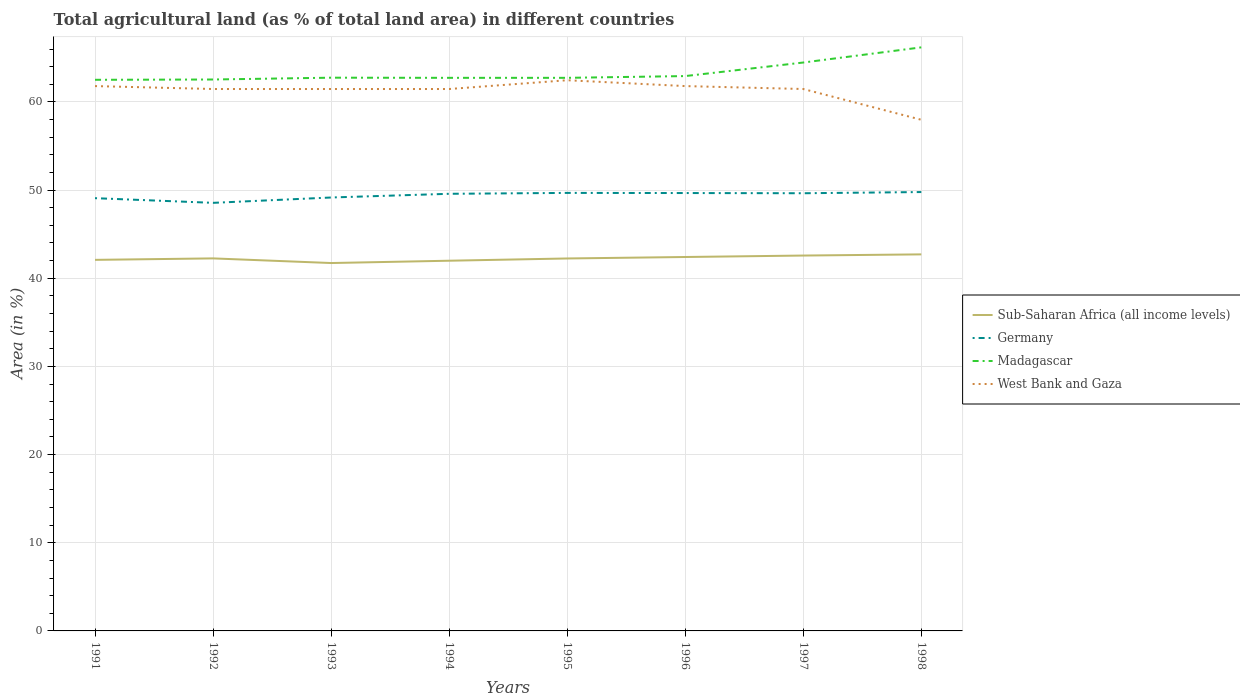Is the number of lines equal to the number of legend labels?
Keep it short and to the point. Yes. Across all years, what is the maximum percentage of agricultural land in Germany?
Your response must be concise. 48.55. What is the total percentage of agricultural land in Germany in the graph?
Your answer should be very brief. -0.09. What is the difference between the highest and the second highest percentage of agricultural land in Sub-Saharan Africa (all income levels)?
Provide a short and direct response. 0.98. What is the difference between the highest and the lowest percentage of agricultural land in Sub-Saharan Africa (all income levels)?
Ensure brevity in your answer.  4. What is the difference between two consecutive major ticks on the Y-axis?
Offer a very short reply. 10. Are the values on the major ticks of Y-axis written in scientific E-notation?
Provide a succinct answer. No. How many legend labels are there?
Keep it short and to the point. 4. How are the legend labels stacked?
Keep it short and to the point. Vertical. What is the title of the graph?
Give a very brief answer. Total agricultural land (as % of total land area) in different countries. Does "Guatemala" appear as one of the legend labels in the graph?
Your answer should be compact. No. What is the label or title of the X-axis?
Provide a succinct answer. Years. What is the label or title of the Y-axis?
Your response must be concise. Area (in %). What is the Area (in %) of Sub-Saharan Africa (all income levels) in 1991?
Your answer should be compact. 42.08. What is the Area (in %) in Germany in 1991?
Keep it short and to the point. 49.08. What is the Area (in %) of Madagascar in 1991?
Make the answer very short. 62.51. What is the Area (in %) in West Bank and Gaza in 1991?
Your answer should be very brief. 61.79. What is the Area (in %) in Sub-Saharan Africa (all income levels) in 1992?
Give a very brief answer. 42.25. What is the Area (in %) of Germany in 1992?
Offer a very short reply. 48.55. What is the Area (in %) in Madagascar in 1992?
Keep it short and to the point. 62.54. What is the Area (in %) of West Bank and Gaza in 1992?
Give a very brief answer. 61.46. What is the Area (in %) of Sub-Saharan Africa (all income levels) in 1993?
Your answer should be very brief. 41.72. What is the Area (in %) in Germany in 1993?
Provide a succinct answer. 49.16. What is the Area (in %) in Madagascar in 1993?
Your answer should be compact. 62.75. What is the Area (in %) of West Bank and Gaza in 1993?
Provide a succinct answer. 61.46. What is the Area (in %) in Sub-Saharan Africa (all income levels) in 1994?
Provide a short and direct response. 41.99. What is the Area (in %) in Germany in 1994?
Ensure brevity in your answer.  49.58. What is the Area (in %) of Madagascar in 1994?
Make the answer very short. 62.73. What is the Area (in %) in West Bank and Gaza in 1994?
Your answer should be compact. 61.46. What is the Area (in %) in Sub-Saharan Africa (all income levels) in 1995?
Provide a succinct answer. 42.24. What is the Area (in %) in Germany in 1995?
Ensure brevity in your answer.  49.68. What is the Area (in %) of Madagascar in 1995?
Offer a very short reply. 62.73. What is the Area (in %) of West Bank and Gaza in 1995?
Make the answer very short. 62.46. What is the Area (in %) of Sub-Saharan Africa (all income levels) in 1996?
Make the answer very short. 42.41. What is the Area (in %) of Germany in 1996?
Provide a short and direct response. 49.66. What is the Area (in %) of Madagascar in 1996?
Provide a succinct answer. 62.93. What is the Area (in %) in West Bank and Gaza in 1996?
Provide a succinct answer. 61.79. What is the Area (in %) of Sub-Saharan Africa (all income levels) in 1997?
Your answer should be very brief. 42.57. What is the Area (in %) of Germany in 1997?
Give a very brief answer. 49.64. What is the Area (in %) of Madagascar in 1997?
Your answer should be compact. 64.47. What is the Area (in %) of West Bank and Gaza in 1997?
Your answer should be compact. 61.46. What is the Area (in %) in Sub-Saharan Africa (all income levels) in 1998?
Your answer should be compact. 42.71. What is the Area (in %) in Germany in 1998?
Your answer should be very brief. 49.78. What is the Area (in %) in Madagascar in 1998?
Offer a terse response. 66.19. What is the Area (in %) of West Bank and Gaza in 1998?
Provide a succinct answer. 57.97. Across all years, what is the maximum Area (in %) of Sub-Saharan Africa (all income levels)?
Provide a short and direct response. 42.71. Across all years, what is the maximum Area (in %) in Germany?
Your answer should be very brief. 49.78. Across all years, what is the maximum Area (in %) of Madagascar?
Give a very brief answer. 66.19. Across all years, what is the maximum Area (in %) of West Bank and Gaza?
Your answer should be very brief. 62.46. Across all years, what is the minimum Area (in %) in Sub-Saharan Africa (all income levels)?
Your answer should be compact. 41.72. Across all years, what is the minimum Area (in %) of Germany?
Make the answer very short. 48.55. Across all years, what is the minimum Area (in %) of Madagascar?
Your answer should be very brief. 62.51. Across all years, what is the minimum Area (in %) of West Bank and Gaza?
Make the answer very short. 57.97. What is the total Area (in %) in Sub-Saharan Africa (all income levels) in the graph?
Offer a very short reply. 337.98. What is the total Area (in %) in Germany in the graph?
Ensure brevity in your answer.  395.13. What is the total Area (in %) of Madagascar in the graph?
Offer a very short reply. 506.84. What is the total Area (in %) in West Bank and Gaza in the graph?
Make the answer very short. 489.87. What is the difference between the Area (in %) of Sub-Saharan Africa (all income levels) in 1991 and that in 1992?
Provide a succinct answer. -0.17. What is the difference between the Area (in %) in Germany in 1991 and that in 1992?
Give a very brief answer. 0.53. What is the difference between the Area (in %) in Madagascar in 1991 and that in 1992?
Offer a very short reply. -0.03. What is the difference between the Area (in %) in West Bank and Gaza in 1991 and that in 1992?
Offer a very short reply. 0.33. What is the difference between the Area (in %) of Sub-Saharan Africa (all income levels) in 1991 and that in 1993?
Your answer should be very brief. 0.36. What is the difference between the Area (in %) of Germany in 1991 and that in 1993?
Give a very brief answer. -0.08. What is the difference between the Area (in %) in Madagascar in 1991 and that in 1993?
Your answer should be compact. -0.24. What is the difference between the Area (in %) in West Bank and Gaza in 1991 and that in 1993?
Provide a short and direct response. 0.33. What is the difference between the Area (in %) in Sub-Saharan Africa (all income levels) in 1991 and that in 1994?
Your answer should be compact. 0.1. What is the difference between the Area (in %) in Germany in 1991 and that in 1994?
Provide a succinct answer. -0.5. What is the difference between the Area (in %) of Madagascar in 1991 and that in 1994?
Keep it short and to the point. -0.22. What is the difference between the Area (in %) of West Bank and Gaza in 1991 and that in 1994?
Ensure brevity in your answer.  0.33. What is the difference between the Area (in %) in Sub-Saharan Africa (all income levels) in 1991 and that in 1995?
Offer a very short reply. -0.16. What is the difference between the Area (in %) of Germany in 1991 and that in 1995?
Your answer should be compact. -0.6. What is the difference between the Area (in %) in Madagascar in 1991 and that in 1995?
Give a very brief answer. -0.22. What is the difference between the Area (in %) of West Bank and Gaza in 1991 and that in 1995?
Make the answer very short. -0.66. What is the difference between the Area (in %) in Sub-Saharan Africa (all income levels) in 1991 and that in 1996?
Provide a short and direct response. -0.32. What is the difference between the Area (in %) of Germany in 1991 and that in 1996?
Provide a short and direct response. -0.58. What is the difference between the Area (in %) in Madagascar in 1991 and that in 1996?
Your response must be concise. -0.42. What is the difference between the Area (in %) of Sub-Saharan Africa (all income levels) in 1991 and that in 1997?
Provide a succinct answer. -0.49. What is the difference between the Area (in %) in Germany in 1991 and that in 1997?
Offer a terse response. -0.56. What is the difference between the Area (in %) of Madagascar in 1991 and that in 1997?
Make the answer very short. -1.96. What is the difference between the Area (in %) in West Bank and Gaza in 1991 and that in 1997?
Offer a very short reply. 0.33. What is the difference between the Area (in %) in Sub-Saharan Africa (all income levels) in 1991 and that in 1998?
Keep it short and to the point. -0.62. What is the difference between the Area (in %) in Germany in 1991 and that in 1998?
Give a very brief answer. -0.69. What is the difference between the Area (in %) of Madagascar in 1991 and that in 1998?
Offer a very short reply. -3.68. What is the difference between the Area (in %) of West Bank and Gaza in 1991 and that in 1998?
Provide a succinct answer. 3.82. What is the difference between the Area (in %) in Sub-Saharan Africa (all income levels) in 1992 and that in 1993?
Ensure brevity in your answer.  0.53. What is the difference between the Area (in %) of Germany in 1992 and that in 1993?
Your answer should be compact. -0.61. What is the difference between the Area (in %) in Madagascar in 1992 and that in 1993?
Offer a terse response. -0.21. What is the difference between the Area (in %) of Sub-Saharan Africa (all income levels) in 1992 and that in 1994?
Your response must be concise. 0.26. What is the difference between the Area (in %) in Germany in 1992 and that in 1994?
Offer a terse response. -1.03. What is the difference between the Area (in %) of Madagascar in 1992 and that in 1994?
Offer a very short reply. -0.19. What is the difference between the Area (in %) in Sub-Saharan Africa (all income levels) in 1992 and that in 1995?
Your response must be concise. 0.01. What is the difference between the Area (in %) of Germany in 1992 and that in 1995?
Offer a very short reply. -1.13. What is the difference between the Area (in %) of Madagascar in 1992 and that in 1995?
Provide a short and direct response. -0.19. What is the difference between the Area (in %) in West Bank and Gaza in 1992 and that in 1995?
Ensure brevity in your answer.  -1. What is the difference between the Area (in %) of Sub-Saharan Africa (all income levels) in 1992 and that in 1996?
Offer a terse response. -0.16. What is the difference between the Area (in %) in Germany in 1992 and that in 1996?
Provide a succinct answer. -1.11. What is the difference between the Area (in %) in Madagascar in 1992 and that in 1996?
Keep it short and to the point. -0.39. What is the difference between the Area (in %) in West Bank and Gaza in 1992 and that in 1996?
Make the answer very short. -0.33. What is the difference between the Area (in %) in Sub-Saharan Africa (all income levels) in 1992 and that in 1997?
Provide a short and direct response. -0.32. What is the difference between the Area (in %) in Germany in 1992 and that in 1997?
Offer a very short reply. -1.09. What is the difference between the Area (in %) in Madagascar in 1992 and that in 1997?
Your answer should be very brief. -1.93. What is the difference between the Area (in %) in Sub-Saharan Africa (all income levels) in 1992 and that in 1998?
Your answer should be very brief. -0.46. What is the difference between the Area (in %) in Germany in 1992 and that in 1998?
Give a very brief answer. -1.22. What is the difference between the Area (in %) in Madagascar in 1992 and that in 1998?
Your answer should be very brief. -3.65. What is the difference between the Area (in %) of West Bank and Gaza in 1992 and that in 1998?
Give a very brief answer. 3.49. What is the difference between the Area (in %) of Sub-Saharan Africa (all income levels) in 1993 and that in 1994?
Provide a short and direct response. -0.26. What is the difference between the Area (in %) of Germany in 1993 and that in 1994?
Ensure brevity in your answer.  -0.42. What is the difference between the Area (in %) of Madagascar in 1993 and that in 1994?
Your response must be concise. 0.02. What is the difference between the Area (in %) of Sub-Saharan Africa (all income levels) in 1993 and that in 1995?
Your answer should be compact. -0.52. What is the difference between the Area (in %) in Germany in 1993 and that in 1995?
Provide a short and direct response. -0.52. What is the difference between the Area (in %) of Madagascar in 1993 and that in 1995?
Make the answer very short. 0.02. What is the difference between the Area (in %) in West Bank and Gaza in 1993 and that in 1995?
Offer a very short reply. -1. What is the difference between the Area (in %) of Sub-Saharan Africa (all income levels) in 1993 and that in 1996?
Your answer should be compact. -0.68. What is the difference between the Area (in %) in Germany in 1993 and that in 1996?
Your answer should be very brief. -0.51. What is the difference between the Area (in %) in Madagascar in 1993 and that in 1996?
Offer a very short reply. -0.18. What is the difference between the Area (in %) in West Bank and Gaza in 1993 and that in 1996?
Your answer should be very brief. -0.33. What is the difference between the Area (in %) in Sub-Saharan Africa (all income levels) in 1993 and that in 1997?
Make the answer very short. -0.85. What is the difference between the Area (in %) of Germany in 1993 and that in 1997?
Ensure brevity in your answer.  -0.48. What is the difference between the Area (in %) in Madagascar in 1993 and that in 1997?
Make the answer very short. -1.72. What is the difference between the Area (in %) of Sub-Saharan Africa (all income levels) in 1993 and that in 1998?
Provide a succinct answer. -0.98. What is the difference between the Area (in %) in Germany in 1993 and that in 1998?
Make the answer very short. -0.62. What is the difference between the Area (in %) in Madagascar in 1993 and that in 1998?
Keep it short and to the point. -3.44. What is the difference between the Area (in %) in West Bank and Gaza in 1993 and that in 1998?
Offer a terse response. 3.49. What is the difference between the Area (in %) in Sub-Saharan Africa (all income levels) in 1994 and that in 1995?
Keep it short and to the point. -0.26. What is the difference between the Area (in %) of Germany in 1994 and that in 1995?
Keep it short and to the point. -0.1. What is the difference between the Area (in %) of Madagascar in 1994 and that in 1995?
Provide a short and direct response. 0. What is the difference between the Area (in %) of West Bank and Gaza in 1994 and that in 1995?
Your response must be concise. -1. What is the difference between the Area (in %) in Sub-Saharan Africa (all income levels) in 1994 and that in 1996?
Your answer should be very brief. -0.42. What is the difference between the Area (in %) in Germany in 1994 and that in 1996?
Ensure brevity in your answer.  -0.09. What is the difference between the Area (in %) in Madagascar in 1994 and that in 1996?
Your answer should be compact. -0.2. What is the difference between the Area (in %) in West Bank and Gaza in 1994 and that in 1996?
Give a very brief answer. -0.33. What is the difference between the Area (in %) in Sub-Saharan Africa (all income levels) in 1994 and that in 1997?
Provide a short and direct response. -0.59. What is the difference between the Area (in %) in Germany in 1994 and that in 1997?
Provide a succinct answer. -0.06. What is the difference between the Area (in %) of Madagascar in 1994 and that in 1997?
Make the answer very short. -1.74. What is the difference between the Area (in %) in West Bank and Gaza in 1994 and that in 1997?
Your answer should be compact. 0. What is the difference between the Area (in %) in Sub-Saharan Africa (all income levels) in 1994 and that in 1998?
Your answer should be very brief. -0.72. What is the difference between the Area (in %) in Germany in 1994 and that in 1998?
Offer a terse response. -0.2. What is the difference between the Area (in %) in Madagascar in 1994 and that in 1998?
Provide a succinct answer. -3.46. What is the difference between the Area (in %) of West Bank and Gaza in 1994 and that in 1998?
Your answer should be compact. 3.49. What is the difference between the Area (in %) of Sub-Saharan Africa (all income levels) in 1995 and that in 1996?
Keep it short and to the point. -0.17. What is the difference between the Area (in %) in Germany in 1995 and that in 1996?
Offer a very short reply. 0.02. What is the difference between the Area (in %) of Madagascar in 1995 and that in 1996?
Make the answer very short. -0.2. What is the difference between the Area (in %) of West Bank and Gaza in 1995 and that in 1996?
Ensure brevity in your answer.  0.66. What is the difference between the Area (in %) in Sub-Saharan Africa (all income levels) in 1995 and that in 1997?
Offer a very short reply. -0.33. What is the difference between the Area (in %) of Germany in 1995 and that in 1997?
Make the answer very short. 0.04. What is the difference between the Area (in %) in Madagascar in 1995 and that in 1997?
Offer a very short reply. -1.74. What is the difference between the Area (in %) of West Bank and Gaza in 1995 and that in 1997?
Your answer should be compact. 1. What is the difference between the Area (in %) in Sub-Saharan Africa (all income levels) in 1995 and that in 1998?
Give a very brief answer. -0.46. What is the difference between the Area (in %) of Germany in 1995 and that in 1998?
Provide a succinct answer. -0.1. What is the difference between the Area (in %) of Madagascar in 1995 and that in 1998?
Provide a short and direct response. -3.46. What is the difference between the Area (in %) in West Bank and Gaza in 1995 and that in 1998?
Provide a succinct answer. 4.49. What is the difference between the Area (in %) in Sub-Saharan Africa (all income levels) in 1996 and that in 1997?
Ensure brevity in your answer.  -0.17. What is the difference between the Area (in %) in Germany in 1996 and that in 1997?
Provide a succinct answer. 0.02. What is the difference between the Area (in %) in Madagascar in 1996 and that in 1997?
Give a very brief answer. -1.54. What is the difference between the Area (in %) in West Bank and Gaza in 1996 and that in 1997?
Make the answer very short. 0.33. What is the difference between the Area (in %) in Sub-Saharan Africa (all income levels) in 1996 and that in 1998?
Provide a succinct answer. -0.3. What is the difference between the Area (in %) of Germany in 1996 and that in 1998?
Offer a very short reply. -0.11. What is the difference between the Area (in %) of Madagascar in 1996 and that in 1998?
Provide a succinct answer. -3.26. What is the difference between the Area (in %) in West Bank and Gaza in 1996 and that in 1998?
Provide a short and direct response. 3.82. What is the difference between the Area (in %) of Sub-Saharan Africa (all income levels) in 1997 and that in 1998?
Offer a very short reply. -0.13. What is the difference between the Area (in %) in Germany in 1997 and that in 1998?
Offer a very short reply. -0.14. What is the difference between the Area (in %) in Madagascar in 1997 and that in 1998?
Give a very brief answer. -1.72. What is the difference between the Area (in %) in West Bank and Gaza in 1997 and that in 1998?
Provide a succinct answer. 3.49. What is the difference between the Area (in %) in Sub-Saharan Africa (all income levels) in 1991 and the Area (in %) in Germany in 1992?
Provide a short and direct response. -6.47. What is the difference between the Area (in %) of Sub-Saharan Africa (all income levels) in 1991 and the Area (in %) of Madagascar in 1992?
Give a very brief answer. -20.46. What is the difference between the Area (in %) in Sub-Saharan Africa (all income levels) in 1991 and the Area (in %) in West Bank and Gaza in 1992?
Your response must be concise. -19.38. What is the difference between the Area (in %) of Germany in 1991 and the Area (in %) of Madagascar in 1992?
Give a very brief answer. -13.46. What is the difference between the Area (in %) of Germany in 1991 and the Area (in %) of West Bank and Gaza in 1992?
Ensure brevity in your answer.  -12.38. What is the difference between the Area (in %) of Madagascar in 1991 and the Area (in %) of West Bank and Gaza in 1992?
Provide a succinct answer. 1.04. What is the difference between the Area (in %) of Sub-Saharan Africa (all income levels) in 1991 and the Area (in %) of Germany in 1993?
Offer a terse response. -7.07. What is the difference between the Area (in %) in Sub-Saharan Africa (all income levels) in 1991 and the Area (in %) in Madagascar in 1993?
Provide a succinct answer. -20.66. What is the difference between the Area (in %) in Sub-Saharan Africa (all income levels) in 1991 and the Area (in %) in West Bank and Gaza in 1993?
Give a very brief answer. -19.38. What is the difference between the Area (in %) in Germany in 1991 and the Area (in %) in Madagascar in 1993?
Make the answer very short. -13.67. What is the difference between the Area (in %) of Germany in 1991 and the Area (in %) of West Bank and Gaza in 1993?
Your answer should be very brief. -12.38. What is the difference between the Area (in %) in Madagascar in 1991 and the Area (in %) in West Bank and Gaza in 1993?
Make the answer very short. 1.04. What is the difference between the Area (in %) of Sub-Saharan Africa (all income levels) in 1991 and the Area (in %) of Germany in 1994?
Your answer should be compact. -7.49. What is the difference between the Area (in %) in Sub-Saharan Africa (all income levels) in 1991 and the Area (in %) in Madagascar in 1994?
Your answer should be very brief. -20.65. What is the difference between the Area (in %) in Sub-Saharan Africa (all income levels) in 1991 and the Area (in %) in West Bank and Gaza in 1994?
Ensure brevity in your answer.  -19.38. What is the difference between the Area (in %) of Germany in 1991 and the Area (in %) of Madagascar in 1994?
Provide a short and direct response. -13.65. What is the difference between the Area (in %) in Germany in 1991 and the Area (in %) in West Bank and Gaza in 1994?
Give a very brief answer. -12.38. What is the difference between the Area (in %) of Madagascar in 1991 and the Area (in %) of West Bank and Gaza in 1994?
Provide a short and direct response. 1.04. What is the difference between the Area (in %) of Sub-Saharan Africa (all income levels) in 1991 and the Area (in %) of Germany in 1995?
Provide a succinct answer. -7.59. What is the difference between the Area (in %) in Sub-Saharan Africa (all income levels) in 1991 and the Area (in %) in Madagascar in 1995?
Provide a short and direct response. -20.65. What is the difference between the Area (in %) of Sub-Saharan Africa (all income levels) in 1991 and the Area (in %) of West Bank and Gaza in 1995?
Provide a short and direct response. -20.37. What is the difference between the Area (in %) of Germany in 1991 and the Area (in %) of Madagascar in 1995?
Your answer should be very brief. -13.65. What is the difference between the Area (in %) in Germany in 1991 and the Area (in %) in West Bank and Gaza in 1995?
Your answer should be very brief. -13.38. What is the difference between the Area (in %) of Madagascar in 1991 and the Area (in %) of West Bank and Gaza in 1995?
Give a very brief answer. 0.05. What is the difference between the Area (in %) in Sub-Saharan Africa (all income levels) in 1991 and the Area (in %) in Germany in 1996?
Offer a terse response. -7.58. What is the difference between the Area (in %) of Sub-Saharan Africa (all income levels) in 1991 and the Area (in %) of Madagascar in 1996?
Ensure brevity in your answer.  -20.84. What is the difference between the Area (in %) of Sub-Saharan Africa (all income levels) in 1991 and the Area (in %) of West Bank and Gaza in 1996?
Your answer should be very brief. -19.71. What is the difference between the Area (in %) in Germany in 1991 and the Area (in %) in Madagascar in 1996?
Ensure brevity in your answer.  -13.85. What is the difference between the Area (in %) in Germany in 1991 and the Area (in %) in West Bank and Gaza in 1996?
Offer a very short reply. -12.71. What is the difference between the Area (in %) of Madagascar in 1991 and the Area (in %) of West Bank and Gaza in 1996?
Offer a terse response. 0.71. What is the difference between the Area (in %) of Sub-Saharan Africa (all income levels) in 1991 and the Area (in %) of Germany in 1997?
Your answer should be compact. -7.56. What is the difference between the Area (in %) in Sub-Saharan Africa (all income levels) in 1991 and the Area (in %) in Madagascar in 1997?
Provide a succinct answer. -22.38. What is the difference between the Area (in %) of Sub-Saharan Africa (all income levels) in 1991 and the Area (in %) of West Bank and Gaza in 1997?
Keep it short and to the point. -19.38. What is the difference between the Area (in %) in Germany in 1991 and the Area (in %) in Madagascar in 1997?
Make the answer very short. -15.38. What is the difference between the Area (in %) of Germany in 1991 and the Area (in %) of West Bank and Gaza in 1997?
Keep it short and to the point. -12.38. What is the difference between the Area (in %) in Madagascar in 1991 and the Area (in %) in West Bank and Gaza in 1997?
Provide a succinct answer. 1.04. What is the difference between the Area (in %) in Sub-Saharan Africa (all income levels) in 1991 and the Area (in %) in Germany in 1998?
Make the answer very short. -7.69. What is the difference between the Area (in %) of Sub-Saharan Africa (all income levels) in 1991 and the Area (in %) of Madagascar in 1998?
Give a very brief answer. -24.1. What is the difference between the Area (in %) in Sub-Saharan Africa (all income levels) in 1991 and the Area (in %) in West Bank and Gaza in 1998?
Your answer should be very brief. -15.89. What is the difference between the Area (in %) of Germany in 1991 and the Area (in %) of Madagascar in 1998?
Give a very brief answer. -17.1. What is the difference between the Area (in %) of Germany in 1991 and the Area (in %) of West Bank and Gaza in 1998?
Keep it short and to the point. -8.89. What is the difference between the Area (in %) of Madagascar in 1991 and the Area (in %) of West Bank and Gaza in 1998?
Your response must be concise. 4.53. What is the difference between the Area (in %) in Sub-Saharan Africa (all income levels) in 1992 and the Area (in %) in Germany in 1993?
Make the answer very short. -6.91. What is the difference between the Area (in %) in Sub-Saharan Africa (all income levels) in 1992 and the Area (in %) in Madagascar in 1993?
Your answer should be very brief. -20.5. What is the difference between the Area (in %) of Sub-Saharan Africa (all income levels) in 1992 and the Area (in %) of West Bank and Gaza in 1993?
Your response must be concise. -19.21. What is the difference between the Area (in %) of Germany in 1992 and the Area (in %) of Madagascar in 1993?
Give a very brief answer. -14.2. What is the difference between the Area (in %) in Germany in 1992 and the Area (in %) in West Bank and Gaza in 1993?
Offer a terse response. -12.91. What is the difference between the Area (in %) of Madagascar in 1992 and the Area (in %) of West Bank and Gaza in 1993?
Keep it short and to the point. 1.08. What is the difference between the Area (in %) in Sub-Saharan Africa (all income levels) in 1992 and the Area (in %) in Germany in 1994?
Give a very brief answer. -7.33. What is the difference between the Area (in %) of Sub-Saharan Africa (all income levels) in 1992 and the Area (in %) of Madagascar in 1994?
Your response must be concise. -20.48. What is the difference between the Area (in %) of Sub-Saharan Africa (all income levels) in 1992 and the Area (in %) of West Bank and Gaza in 1994?
Provide a succinct answer. -19.21. What is the difference between the Area (in %) in Germany in 1992 and the Area (in %) in Madagascar in 1994?
Offer a very short reply. -14.18. What is the difference between the Area (in %) of Germany in 1992 and the Area (in %) of West Bank and Gaza in 1994?
Keep it short and to the point. -12.91. What is the difference between the Area (in %) in Madagascar in 1992 and the Area (in %) in West Bank and Gaza in 1994?
Ensure brevity in your answer.  1.08. What is the difference between the Area (in %) in Sub-Saharan Africa (all income levels) in 1992 and the Area (in %) in Germany in 1995?
Give a very brief answer. -7.43. What is the difference between the Area (in %) in Sub-Saharan Africa (all income levels) in 1992 and the Area (in %) in Madagascar in 1995?
Your response must be concise. -20.48. What is the difference between the Area (in %) in Sub-Saharan Africa (all income levels) in 1992 and the Area (in %) in West Bank and Gaza in 1995?
Offer a terse response. -20.21. What is the difference between the Area (in %) in Germany in 1992 and the Area (in %) in Madagascar in 1995?
Your answer should be very brief. -14.18. What is the difference between the Area (in %) in Germany in 1992 and the Area (in %) in West Bank and Gaza in 1995?
Your response must be concise. -13.91. What is the difference between the Area (in %) in Madagascar in 1992 and the Area (in %) in West Bank and Gaza in 1995?
Provide a short and direct response. 0.08. What is the difference between the Area (in %) of Sub-Saharan Africa (all income levels) in 1992 and the Area (in %) of Germany in 1996?
Offer a terse response. -7.41. What is the difference between the Area (in %) in Sub-Saharan Africa (all income levels) in 1992 and the Area (in %) in Madagascar in 1996?
Give a very brief answer. -20.68. What is the difference between the Area (in %) of Sub-Saharan Africa (all income levels) in 1992 and the Area (in %) of West Bank and Gaza in 1996?
Keep it short and to the point. -19.54. What is the difference between the Area (in %) in Germany in 1992 and the Area (in %) in Madagascar in 1996?
Your answer should be compact. -14.38. What is the difference between the Area (in %) of Germany in 1992 and the Area (in %) of West Bank and Gaza in 1996?
Offer a terse response. -13.24. What is the difference between the Area (in %) in Madagascar in 1992 and the Area (in %) in West Bank and Gaza in 1996?
Your response must be concise. 0.75. What is the difference between the Area (in %) in Sub-Saharan Africa (all income levels) in 1992 and the Area (in %) in Germany in 1997?
Make the answer very short. -7.39. What is the difference between the Area (in %) in Sub-Saharan Africa (all income levels) in 1992 and the Area (in %) in Madagascar in 1997?
Ensure brevity in your answer.  -22.22. What is the difference between the Area (in %) in Sub-Saharan Africa (all income levels) in 1992 and the Area (in %) in West Bank and Gaza in 1997?
Offer a terse response. -19.21. What is the difference between the Area (in %) in Germany in 1992 and the Area (in %) in Madagascar in 1997?
Your answer should be very brief. -15.91. What is the difference between the Area (in %) of Germany in 1992 and the Area (in %) of West Bank and Gaza in 1997?
Offer a very short reply. -12.91. What is the difference between the Area (in %) of Madagascar in 1992 and the Area (in %) of West Bank and Gaza in 1997?
Give a very brief answer. 1.08. What is the difference between the Area (in %) of Sub-Saharan Africa (all income levels) in 1992 and the Area (in %) of Germany in 1998?
Make the answer very short. -7.53. What is the difference between the Area (in %) in Sub-Saharan Africa (all income levels) in 1992 and the Area (in %) in Madagascar in 1998?
Offer a very short reply. -23.94. What is the difference between the Area (in %) in Sub-Saharan Africa (all income levels) in 1992 and the Area (in %) in West Bank and Gaza in 1998?
Offer a terse response. -15.72. What is the difference between the Area (in %) in Germany in 1992 and the Area (in %) in Madagascar in 1998?
Provide a short and direct response. -17.63. What is the difference between the Area (in %) of Germany in 1992 and the Area (in %) of West Bank and Gaza in 1998?
Provide a short and direct response. -9.42. What is the difference between the Area (in %) in Madagascar in 1992 and the Area (in %) in West Bank and Gaza in 1998?
Ensure brevity in your answer.  4.57. What is the difference between the Area (in %) of Sub-Saharan Africa (all income levels) in 1993 and the Area (in %) of Germany in 1994?
Offer a terse response. -7.85. What is the difference between the Area (in %) of Sub-Saharan Africa (all income levels) in 1993 and the Area (in %) of Madagascar in 1994?
Keep it short and to the point. -21.01. What is the difference between the Area (in %) of Sub-Saharan Africa (all income levels) in 1993 and the Area (in %) of West Bank and Gaza in 1994?
Offer a terse response. -19.74. What is the difference between the Area (in %) of Germany in 1993 and the Area (in %) of Madagascar in 1994?
Make the answer very short. -13.57. What is the difference between the Area (in %) of Germany in 1993 and the Area (in %) of West Bank and Gaza in 1994?
Ensure brevity in your answer.  -12.3. What is the difference between the Area (in %) in Madagascar in 1993 and the Area (in %) in West Bank and Gaza in 1994?
Your response must be concise. 1.29. What is the difference between the Area (in %) in Sub-Saharan Africa (all income levels) in 1993 and the Area (in %) in Germany in 1995?
Your answer should be very brief. -7.95. What is the difference between the Area (in %) of Sub-Saharan Africa (all income levels) in 1993 and the Area (in %) of Madagascar in 1995?
Provide a short and direct response. -21.01. What is the difference between the Area (in %) in Sub-Saharan Africa (all income levels) in 1993 and the Area (in %) in West Bank and Gaza in 1995?
Provide a short and direct response. -20.73. What is the difference between the Area (in %) of Germany in 1993 and the Area (in %) of Madagascar in 1995?
Make the answer very short. -13.57. What is the difference between the Area (in %) of Germany in 1993 and the Area (in %) of West Bank and Gaza in 1995?
Your answer should be compact. -13.3. What is the difference between the Area (in %) of Madagascar in 1993 and the Area (in %) of West Bank and Gaza in 1995?
Your answer should be very brief. 0.29. What is the difference between the Area (in %) of Sub-Saharan Africa (all income levels) in 1993 and the Area (in %) of Germany in 1996?
Your response must be concise. -7.94. What is the difference between the Area (in %) in Sub-Saharan Africa (all income levels) in 1993 and the Area (in %) in Madagascar in 1996?
Offer a terse response. -21.2. What is the difference between the Area (in %) in Sub-Saharan Africa (all income levels) in 1993 and the Area (in %) in West Bank and Gaza in 1996?
Ensure brevity in your answer.  -20.07. What is the difference between the Area (in %) in Germany in 1993 and the Area (in %) in Madagascar in 1996?
Ensure brevity in your answer.  -13.77. What is the difference between the Area (in %) of Germany in 1993 and the Area (in %) of West Bank and Gaza in 1996?
Give a very brief answer. -12.64. What is the difference between the Area (in %) of Madagascar in 1993 and the Area (in %) of West Bank and Gaza in 1996?
Offer a very short reply. 0.95. What is the difference between the Area (in %) in Sub-Saharan Africa (all income levels) in 1993 and the Area (in %) in Germany in 1997?
Provide a succinct answer. -7.92. What is the difference between the Area (in %) of Sub-Saharan Africa (all income levels) in 1993 and the Area (in %) of Madagascar in 1997?
Offer a very short reply. -22.74. What is the difference between the Area (in %) of Sub-Saharan Africa (all income levels) in 1993 and the Area (in %) of West Bank and Gaza in 1997?
Ensure brevity in your answer.  -19.74. What is the difference between the Area (in %) in Germany in 1993 and the Area (in %) in Madagascar in 1997?
Give a very brief answer. -15.31. What is the difference between the Area (in %) in Germany in 1993 and the Area (in %) in West Bank and Gaza in 1997?
Make the answer very short. -12.3. What is the difference between the Area (in %) in Madagascar in 1993 and the Area (in %) in West Bank and Gaza in 1997?
Your answer should be very brief. 1.29. What is the difference between the Area (in %) in Sub-Saharan Africa (all income levels) in 1993 and the Area (in %) in Germany in 1998?
Your answer should be compact. -8.05. What is the difference between the Area (in %) in Sub-Saharan Africa (all income levels) in 1993 and the Area (in %) in Madagascar in 1998?
Your answer should be very brief. -24.46. What is the difference between the Area (in %) of Sub-Saharan Africa (all income levels) in 1993 and the Area (in %) of West Bank and Gaza in 1998?
Your answer should be very brief. -16.25. What is the difference between the Area (in %) of Germany in 1993 and the Area (in %) of Madagascar in 1998?
Provide a short and direct response. -17.03. What is the difference between the Area (in %) in Germany in 1993 and the Area (in %) in West Bank and Gaza in 1998?
Your answer should be very brief. -8.82. What is the difference between the Area (in %) in Madagascar in 1993 and the Area (in %) in West Bank and Gaza in 1998?
Your answer should be very brief. 4.77. What is the difference between the Area (in %) in Sub-Saharan Africa (all income levels) in 1994 and the Area (in %) in Germany in 1995?
Provide a short and direct response. -7.69. What is the difference between the Area (in %) in Sub-Saharan Africa (all income levels) in 1994 and the Area (in %) in Madagascar in 1995?
Give a very brief answer. -20.74. What is the difference between the Area (in %) in Sub-Saharan Africa (all income levels) in 1994 and the Area (in %) in West Bank and Gaza in 1995?
Offer a terse response. -20.47. What is the difference between the Area (in %) in Germany in 1994 and the Area (in %) in Madagascar in 1995?
Your answer should be very brief. -13.15. What is the difference between the Area (in %) of Germany in 1994 and the Area (in %) of West Bank and Gaza in 1995?
Provide a short and direct response. -12.88. What is the difference between the Area (in %) of Madagascar in 1994 and the Area (in %) of West Bank and Gaza in 1995?
Your answer should be very brief. 0.27. What is the difference between the Area (in %) in Sub-Saharan Africa (all income levels) in 1994 and the Area (in %) in Germany in 1996?
Offer a very short reply. -7.68. What is the difference between the Area (in %) in Sub-Saharan Africa (all income levels) in 1994 and the Area (in %) in Madagascar in 1996?
Make the answer very short. -20.94. What is the difference between the Area (in %) of Sub-Saharan Africa (all income levels) in 1994 and the Area (in %) of West Bank and Gaza in 1996?
Provide a short and direct response. -19.81. What is the difference between the Area (in %) of Germany in 1994 and the Area (in %) of Madagascar in 1996?
Keep it short and to the point. -13.35. What is the difference between the Area (in %) of Germany in 1994 and the Area (in %) of West Bank and Gaza in 1996?
Your answer should be very brief. -12.22. What is the difference between the Area (in %) of Madagascar in 1994 and the Area (in %) of West Bank and Gaza in 1996?
Make the answer very short. 0.94. What is the difference between the Area (in %) of Sub-Saharan Africa (all income levels) in 1994 and the Area (in %) of Germany in 1997?
Make the answer very short. -7.65. What is the difference between the Area (in %) in Sub-Saharan Africa (all income levels) in 1994 and the Area (in %) in Madagascar in 1997?
Offer a very short reply. -22.48. What is the difference between the Area (in %) of Sub-Saharan Africa (all income levels) in 1994 and the Area (in %) of West Bank and Gaza in 1997?
Keep it short and to the point. -19.47. What is the difference between the Area (in %) of Germany in 1994 and the Area (in %) of Madagascar in 1997?
Your answer should be compact. -14.89. What is the difference between the Area (in %) of Germany in 1994 and the Area (in %) of West Bank and Gaza in 1997?
Give a very brief answer. -11.88. What is the difference between the Area (in %) of Madagascar in 1994 and the Area (in %) of West Bank and Gaza in 1997?
Ensure brevity in your answer.  1.27. What is the difference between the Area (in %) in Sub-Saharan Africa (all income levels) in 1994 and the Area (in %) in Germany in 1998?
Keep it short and to the point. -7.79. What is the difference between the Area (in %) in Sub-Saharan Africa (all income levels) in 1994 and the Area (in %) in Madagascar in 1998?
Give a very brief answer. -24.2. What is the difference between the Area (in %) in Sub-Saharan Africa (all income levels) in 1994 and the Area (in %) in West Bank and Gaza in 1998?
Provide a succinct answer. -15.99. What is the difference between the Area (in %) in Germany in 1994 and the Area (in %) in Madagascar in 1998?
Your answer should be very brief. -16.61. What is the difference between the Area (in %) of Germany in 1994 and the Area (in %) of West Bank and Gaza in 1998?
Make the answer very short. -8.4. What is the difference between the Area (in %) of Madagascar in 1994 and the Area (in %) of West Bank and Gaza in 1998?
Offer a terse response. 4.76. What is the difference between the Area (in %) in Sub-Saharan Africa (all income levels) in 1995 and the Area (in %) in Germany in 1996?
Your answer should be very brief. -7.42. What is the difference between the Area (in %) of Sub-Saharan Africa (all income levels) in 1995 and the Area (in %) of Madagascar in 1996?
Provide a succinct answer. -20.69. What is the difference between the Area (in %) of Sub-Saharan Africa (all income levels) in 1995 and the Area (in %) of West Bank and Gaza in 1996?
Offer a terse response. -19.55. What is the difference between the Area (in %) in Germany in 1995 and the Area (in %) in Madagascar in 1996?
Your answer should be compact. -13.25. What is the difference between the Area (in %) of Germany in 1995 and the Area (in %) of West Bank and Gaza in 1996?
Ensure brevity in your answer.  -12.11. What is the difference between the Area (in %) in Madagascar in 1995 and the Area (in %) in West Bank and Gaza in 1996?
Offer a terse response. 0.94. What is the difference between the Area (in %) of Sub-Saharan Africa (all income levels) in 1995 and the Area (in %) of Germany in 1997?
Your answer should be very brief. -7.4. What is the difference between the Area (in %) of Sub-Saharan Africa (all income levels) in 1995 and the Area (in %) of Madagascar in 1997?
Give a very brief answer. -22.22. What is the difference between the Area (in %) of Sub-Saharan Africa (all income levels) in 1995 and the Area (in %) of West Bank and Gaza in 1997?
Your response must be concise. -19.22. What is the difference between the Area (in %) of Germany in 1995 and the Area (in %) of Madagascar in 1997?
Give a very brief answer. -14.79. What is the difference between the Area (in %) in Germany in 1995 and the Area (in %) in West Bank and Gaza in 1997?
Provide a succinct answer. -11.78. What is the difference between the Area (in %) of Madagascar in 1995 and the Area (in %) of West Bank and Gaza in 1997?
Your answer should be compact. 1.27. What is the difference between the Area (in %) in Sub-Saharan Africa (all income levels) in 1995 and the Area (in %) in Germany in 1998?
Keep it short and to the point. -7.53. What is the difference between the Area (in %) in Sub-Saharan Africa (all income levels) in 1995 and the Area (in %) in Madagascar in 1998?
Offer a very short reply. -23.94. What is the difference between the Area (in %) in Sub-Saharan Africa (all income levels) in 1995 and the Area (in %) in West Bank and Gaza in 1998?
Provide a succinct answer. -15.73. What is the difference between the Area (in %) of Germany in 1995 and the Area (in %) of Madagascar in 1998?
Give a very brief answer. -16.51. What is the difference between the Area (in %) in Germany in 1995 and the Area (in %) in West Bank and Gaza in 1998?
Offer a terse response. -8.29. What is the difference between the Area (in %) in Madagascar in 1995 and the Area (in %) in West Bank and Gaza in 1998?
Your answer should be very brief. 4.76. What is the difference between the Area (in %) in Sub-Saharan Africa (all income levels) in 1996 and the Area (in %) in Germany in 1997?
Offer a terse response. -7.23. What is the difference between the Area (in %) of Sub-Saharan Africa (all income levels) in 1996 and the Area (in %) of Madagascar in 1997?
Keep it short and to the point. -22.06. What is the difference between the Area (in %) of Sub-Saharan Africa (all income levels) in 1996 and the Area (in %) of West Bank and Gaza in 1997?
Give a very brief answer. -19.05. What is the difference between the Area (in %) of Germany in 1996 and the Area (in %) of Madagascar in 1997?
Offer a terse response. -14.8. What is the difference between the Area (in %) of Germany in 1996 and the Area (in %) of West Bank and Gaza in 1997?
Your answer should be compact. -11.8. What is the difference between the Area (in %) of Madagascar in 1996 and the Area (in %) of West Bank and Gaza in 1997?
Your answer should be very brief. 1.47. What is the difference between the Area (in %) in Sub-Saharan Africa (all income levels) in 1996 and the Area (in %) in Germany in 1998?
Make the answer very short. -7.37. What is the difference between the Area (in %) in Sub-Saharan Africa (all income levels) in 1996 and the Area (in %) in Madagascar in 1998?
Make the answer very short. -23.78. What is the difference between the Area (in %) of Sub-Saharan Africa (all income levels) in 1996 and the Area (in %) of West Bank and Gaza in 1998?
Ensure brevity in your answer.  -15.56. What is the difference between the Area (in %) in Germany in 1996 and the Area (in %) in Madagascar in 1998?
Give a very brief answer. -16.52. What is the difference between the Area (in %) of Germany in 1996 and the Area (in %) of West Bank and Gaza in 1998?
Make the answer very short. -8.31. What is the difference between the Area (in %) in Madagascar in 1996 and the Area (in %) in West Bank and Gaza in 1998?
Offer a terse response. 4.96. What is the difference between the Area (in %) of Sub-Saharan Africa (all income levels) in 1997 and the Area (in %) of Germany in 1998?
Give a very brief answer. -7.2. What is the difference between the Area (in %) of Sub-Saharan Africa (all income levels) in 1997 and the Area (in %) of Madagascar in 1998?
Keep it short and to the point. -23.61. What is the difference between the Area (in %) in Sub-Saharan Africa (all income levels) in 1997 and the Area (in %) in West Bank and Gaza in 1998?
Your answer should be very brief. -15.4. What is the difference between the Area (in %) of Germany in 1997 and the Area (in %) of Madagascar in 1998?
Your answer should be compact. -16.55. What is the difference between the Area (in %) in Germany in 1997 and the Area (in %) in West Bank and Gaza in 1998?
Keep it short and to the point. -8.33. What is the difference between the Area (in %) in Madagascar in 1997 and the Area (in %) in West Bank and Gaza in 1998?
Offer a very short reply. 6.49. What is the average Area (in %) of Sub-Saharan Africa (all income levels) per year?
Keep it short and to the point. 42.25. What is the average Area (in %) of Germany per year?
Provide a succinct answer. 49.39. What is the average Area (in %) of Madagascar per year?
Your response must be concise. 63.35. What is the average Area (in %) of West Bank and Gaza per year?
Offer a terse response. 61.23. In the year 1991, what is the difference between the Area (in %) of Sub-Saharan Africa (all income levels) and Area (in %) of Germany?
Your answer should be very brief. -7. In the year 1991, what is the difference between the Area (in %) of Sub-Saharan Africa (all income levels) and Area (in %) of Madagascar?
Provide a succinct answer. -20.42. In the year 1991, what is the difference between the Area (in %) in Sub-Saharan Africa (all income levels) and Area (in %) in West Bank and Gaza?
Keep it short and to the point. -19.71. In the year 1991, what is the difference between the Area (in %) in Germany and Area (in %) in Madagascar?
Provide a succinct answer. -13.42. In the year 1991, what is the difference between the Area (in %) in Germany and Area (in %) in West Bank and Gaza?
Provide a short and direct response. -12.71. In the year 1991, what is the difference between the Area (in %) in Madagascar and Area (in %) in West Bank and Gaza?
Make the answer very short. 0.71. In the year 1992, what is the difference between the Area (in %) in Sub-Saharan Africa (all income levels) and Area (in %) in Germany?
Give a very brief answer. -6.3. In the year 1992, what is the difference between the Area (in %) of Sub-Saharan Africa (all income levels) and Area (in %) of Madagascar?
Provide a short and direct response. -20.29. In the year 1992, what is the difference between the Area (in %) of Sub-Saharan Africa (all income levels) and Area (in %) of West Bank and Gaza?
Offer a very short reply. -19.21. In the year 1992, what is the difference between the Area (in %) in Germany and Area (in %) in Madagascar?
Offer a very short reply. -13.99. In the year 1992, what is the difference between the Area (in %) of Germany and Area (in %) of West Bank and Gaza?
Your answer should be very brief. -12.91. In the year 1992, what is the difference between the Area (in %) in Madagascar and Area (in %) in West Bank and Gaza?
Offer a terse response. 1.08. In the year 1993, what is the difference between the Area (in %) in Sub-Saharan Africa (all income levels) and Area (in %) in Germany?
Offer a terse response. -7.43. In the year 1993, what is the difference between the Area (in %) of Sub-Saharan Africa (all income levels) and Area (in %) of Madagascar?
Provide a short and direct response. -21.02. In the year 1993, what is the difference between the Area (in %) in Sub-Saharan Africa (all income levels) and Area (in %) in West Bank and Gaza?
Your answer should be very brief. -19.74. In the year 1993, what is the difference between the Area (in %) of Germany and Area (in %) of Madagascar?
Offer a terse response. -13.59. In the year 1993, what is the difference between the Area (in %) of Germany and Area (in %) of West Bank and Gaza?
Make the answer very short. -12.3. In the year 1993, what is the difference between the Area (in %) in Madagascar and Area (in %) in West Bank and Gaza?
Offer a terse response. 1.29. In the year 1994, what is the difference between the Area (in %) of Sub-Saharan Africa (all income levels) and Area (in %) of Germany?
Ensure brevity in your answer.  -7.59. In the year 1994, what is the difference between the Area (in %) in Sub-Saharan Africa (all income levels) and Area (in %) in Madagascar?
Make the answer very short. -20.74. In the year 1994, what is the difference between the Area (in %) of Sub-Saharan Africa (all income levels) and Area (in %) of West Bank and Gaza?
Ensure brevity in your answer.  -19.47. In the year 1994, what is the difference between the Area (in %) of Germany and Area (in %) of Madagascar?
Ensure brevity in your answer.  -13.15. In the year 1994, what is the difference between the Area (in %) in Germany and Area (in %) in West Bank and Gaza?
Keep it short and to the point. -11.88. In the year 1994, what is the difference between the Area (in %) in Madagascar and Area (in %) in West Bank and Gaza?
Keep it short and to the point. 1.27. In the year 1995, what is the difference between the Area (in %) in Sub-Saharan Africa (all income levels) and Area (in %) in Germany?
Your response must be concise. -7.44. In the year 1995, what is the difference between the Area (in %) of Sub-Saharan Africa (all income levels) and Area (in %) of Madagascar?
Your response must be concise. -20.49. In the year 1995, what is the difference between the Area (in %) of Sub-Saharan Africa (all income levels) and Area (in %) of West Bank and Gaza?
Offer a terse response. -20.22. In the year 1995, what is the difference between the Area (in %) in Germany and Area (in %) in Madagascar?
Provide a succinct answer. -13.05. In the year 1995, what is the difference between the Area (in %) in Germany and Area (in %) in West Bank and Gaza?
Your response must be concise. -12.78. In the year 1995, what is the difference between the Area (in %) of Madagascar and Area (in %) of West Bank and Gaza?
Make the answer very short. 0.27. In the year 1996, what is the difference between the Area (in %) in Sub-Saharan Africa (all income levels) and Area (in %) in Germany?
Provide a succinct answer. -7.25. In the year 1996, what is the difference between the Area (in %) of Sub-Saharan Africa (all income levels) and Area (in %) of Madagascar?
Your answer should be very brief. -20.52. In the year 1996, what is the difference between the Area (in %) of Sub-Saharan Africa (all income levels) and Area (in %) of West Bank and Gaza?
Make the answer very short. -19.39. In the year 1996, what is the difference between the Area (in %) in Germany and Area (in %) in Madagascar?
Make the answer very short. -13.27. In the year 1996, what is the difference between the Area (in %) of Germany and Area (in %) of West Bank and Gaza?
Your answer should be compact. -12.13. In the year 1996, what is the difference between the Area (in %) of Madagascar and Area (in %) of West Bank and Gaza?
Make the answer very short. 1.14. In the year 1997, what is the difference between the Area (in %) in Sub-Saharan Africa (all income levels) and Area (in %) in Germany?
Your response must be concise. -7.07. In the year 1997, what is the difference between the Area (in %) of Sub-Saharan Africa (all income levels) and Area (in %) of Madagascar?
Keep it short and to the point. -21.89. In the year 1997, what is the difference between the Area (in %) of Sub-Saharan Africa (all income levels) and Area (in %) of West Bank and Gaza?
Ensure brevity in your answer.  -18.89. In the year 1997, what is the difference between the Area (in %) of Germany and Area (in %) of Madagascar?
Offer a very short reply. -14.83. In the year 1997, what is the difference between the Area (in %) in Germany and Area (in %) in West Bank and Gaza?
Ensure brevity in your answer.  -11.82. In the year 1997, what is the difference between the Area (in %) in Madagascar and Area (in %) in West Bank and Gaza?
Ensure brevity in your answer.  3. In the year 1998, what is the difference between the Area (in %) in Sub-Saharan Africa (all income levels) and Area (in %) in Germany?
Your answer should be very brief. -7.07. In the year 1998, what is the difference between the Area (in %) of Sub-Saharan Africa (all income levels) and Area (in %) of Madagascar?
Ensure brevity in your answer.  -23.48. In the year 1998, what is the difference between the Area (in %) of Sub-Saharan Africa (all income levels) and Area (in %) of West Bank and Gaza?
Provide a succinct answer. -15.27. In the year 1998, what is the difference between the Area (in %) in Germany and Area (in %) in Madagascar?
Ensure brevity in your answer.  -16.41. In the year 1998, what is the difference between the Area (in %) in Germany and Area (in %) in West Bank and Gaza?
Offer a terse response. -8.2. In the year 1998, what is the difference between the Area (in %) in Madagascar and Area (in %) in West Bank and Gaza?
Make the answer very short. 8.21. What is the ratio of the Area (in %) in Germany in 1991 to that in 1992?
Provide a short and direct response. 1.01. What is the ratio of the Area (in %) in West Bank and Gaza in 1991 to that in 1992?
Provide a short and direct response. 1.01. What is the ratio of the Area (in %) in Sub-Saharan Africa (all income levels) in 1991 to that in 1993?
Your answer should be compact. 1.01. What is the ratio of the Area (in %) in Germany in 1991 to that in 1993?
Provide a short and direct response. 1. What is the ratio of the Area (in %) of West Bank and Gaza in 1991 to that in 1993?
Provide a succinct answer. 1.01. What is the ratio of the Area (in %) in Germany in 1991 to that in 1994?
Your response must be concise. 0.99. What is the ratio of the Area (in %) of West Bank and Gaza in 1991 to that in 1994?
Provide a short and direct response. 1.01. What is the ratio of the Area (in %) in Sub-Saharan Africa (all income levels) in 1991 to that in 1996?
Make the answer very short. 0.99. What is the ratio of the Area (in %) of Germany in 1991 to that in 1996?
Provide a short and direct response. 0.99. What is the ratio of the Area (in %) of Madagascar in 1991 to that in 1996?
Give a very brief answer. 0.99. What is the ratio of the Area (in %) in West Bank and Gaza in 1991 to that in 1996?
Your answer should be very brief. 1. What is the ratio of the Area (in %) in Germany in 1991 to that in 1997?
Offer a terse response. 0.99. What is the ratio of the Area (in %) in Madagascar in 1991 to that in 1997?
Keep it short and to the point. 0.97. What is the ratio of the Area (in %) in West Bank and Gaza in 1991 to that in 1997?
Provide a short and direct response. 1.01. What is the ratio of the Area (in %) in Sub-Saharan Africa (all income levels) in 1991 to that in 1998?
Ensure brevity in your answer.  0.99. What is the ratio of the Area (in %) in Germany in 1991 to that in 1998?
Your response must be concise. 0.99. What is the ratio of the Area (in %) of Madagascar in 1991 to that in 1998?
Your response must be concise. 0.94. What is the ratio of the Area (in %) in West Bank and Gaza in 1991 to that in 1998?
Provide a short and direct response. 1.07. What is the ratio of the Area (in %) of Sub-Saharan Africa (all income levels) in 1992 to that in 1993?
Provide a succinct answer. 1.01. What is the ratio of the Area (in %) in Germany in 1992 to that in 1993?
Keep it short and to the point. 0.99. What is the ratio of the Area (in %) in Sub-Saharan Africa (all income levels) in 1992 to that in 1994?
Provide a succinct answer. 1.01. What is the ratio of the Area (in %) in Germany in 1992 to that in 1994?
Offer a very short reply. 0.98. What is the ratio of the Area (in %) of Madagascar in 1992 to that in 1994?
Provide a succinct answer. 1. What is the ratio of the Area (in %) in Germany in 1992 to that in 1995?
Keep it short and to the point. 0.98. What is the ratio of the Area (in %) in Madagascar in 1992 to that in 1995?
Make the answer very short. 1. What is the ratio of the Area (in %) of Sub-Saharan Africa (all income levels) in 1992 to that in 1996?
Make the answer very short. 1. What is the ratio of the Area (in %) in Germany in 1992 to that in 1996?
Your response must be concise. 0.98. What is the ratio of the Area (in %) of West Bank and Gaza in 1992 to that in 1996?
Keep it short and to the point. 0.99. What is the ratio of the Area (in %) of Sub-Saharan Africa (all income levels) in 1992 to that in 1997?
Offer a terse response. 0.99. What is the ratio of the Area (in %) in Germany in 1992 to that in 1997?
Ensure brevity in your answer.  0.98. What is the ratio of the Area (in %) in Madagascar in 1992 to that in 1997?
Ensure brevity in your answer.  0.97. What is the ratio of the Area (in %) in West Bank and Gaza in 1992 to that in 1997?
Make the answer very short. 1. What is the ratio of the Area (in %) of Sub-Saharan Africa (all income levels) in 1992 to that in 1998?
Provide a short and direct response. 0.99. What is the ratio of the Area (in %) of Germany in 1992 to that in 1998?
Offer a terse response. 0.98. What is the ratio of the Area (in %) in Madagascar in 1992 to that in 1998?
Your answer should be compact. 0.94. What is the ratio of the Area (in %) of West Bank and Gaza in 1992 to that in 1998?
Ensure brevity in your answer.  1.06. What is the ratio of the Area (in %) of Sub-Saharan Africa (all income levels) in 1993 to that in 1994?
Make the answer very short. 0.99. What is the ratio of the Area (in %) in Germany in 1993 to that in 1994?
Your answer should be compact. 0.99. What is the ratio of the Area (in %) of Sub-Saharan Africa (all income levels) in 1993 to that in 1995?
Keep it short and to the point. 0.99. What is the ratio of the Area (in %) in Germany in 1993 to that in 1995?
Offer a very short reply. 0.99. What is the ratio of the Area (in %) in Madagascar in 1993 to that in 1995?
Your response must be concise. 1. What is the ratio of the Area (in %) of West Bank and Gaza in 1993 to that in 1995?
Keep it short and to the point. 0.98. What is the ratio of the Area (in %) of Sub-Saharan Africa (all income levels) in 1993 to that in 1996?
Your answer should be very brief. 0.98. What is the ratio of the Area (in %) of West Bank and Gaza in 1993 to that in 1996?
Offer a terse response. 0.99. What is the ratio of the Area (in %) in Sub-Saharan Africa (all income levels) in 1993 to that in 1997?
Offer a terse response. 0.98. What is the ratio of the Area (in %) of Germany in 1993 to that in 1997?
Your response must be concise. 0.99. What is the ratio of the Area (in %) in Madagascar in 1993 to that in 1997?
Ensure brevity in your answer.  0.97. What is the ratio of the Area (in %) in West Bank and Gaza in 1993 to that in 1997?
Make the answer very short. 1. What is the ratio of the Area (in %) in Germany in 1993 to that in 1998?
Ensure brevity in your answer.  0.99. What is the ratio of the Area (in %) in Madagascar in 1993 to that in 1998?
Keep it short and to the point. 0.95. What is the ratio of the Area (in %) in West Bank and Gaza in 1993 to that in 1998?
Make the answer very short. 1.06. What is the ratio of the Area (in %) of Sub-Saharan Africa (all income levels) in 1994 to that in 1995?
Ensure brevity in your answer.  0.99. What is the ratio of the Area (in %) of Germany in 1994 to that in 1995?
Your response must be concise. 1. What is the ratio of the Area (in %) in Madagascar in 1994 to that in 1995?
Provide a succinct answer. 1. What is the ratio of the Area (in %) in Sub-Saharan Africa (all income levels) in 1994 to that in 1996?
Provide a short and direct response. 0.99. What is the ratio of the Area (in %) of Madagascar in 1994 to that in 1996?
Make the answer very short. 1. What is the ratio of the Area (in %) of Sub-Saharan Africa (all income levels) in 1994 to that in 1997?
Provide a short and direct response. 0.99. What is the ratio of the Area (in %) of Germany in 1994 to that in 1997?
Ensure brevity in your answer.  1. What is the ratio of the Area (in %) of Madagascar in 1994 to that in 1997?
Provide a succinct answer. 0.97. What is the ratio of the Area (in %) of West Bank and Gaza in 1994 to that in 1997?
Provide a succinct answer. 1. What is the ratio of the Area (in %) in Sub-Saharan Africa (all income levels) in 1994 to that in 1998?
Provide a succinct answer. 0.98. What is the ratio of the Area (in %) of Madagascar in 1994 to that in 1998?
Make the answer very short. 0.95. What is the ratio of the Area (in %) of West Bank and Gaza in 1994 to that in 1998?
Keep it short and to the point. 1.06. What is the ratio of the Area (in %) in Sub-Saharan Africa (all income levels) in 1995 to that in 1996?
Offer a very short reply. 1. What is the ratio of the Area (in %) of Madagascar in 1995 to that in 1996?
Make the answer very short. 1. What is the ratio of the Area (in %) of West Bank and Gaza in 1995 to that in 1996?
Make the answer very short. 1.01. What is the ratio of the Area (in %) of Sub-Saharan Africa (all income levels) in 1995 to that in 1997?
Your response must be concise. 0.99. What is the ratio of the Area (in %) in Germany in 1995 to that in 1997?
Provide a short and direct response. 1. What is the ratio of the Area (in %) in Madagascar in 1995 to that in 1997?
Offer a terse response. 0.97. What is the ratio of the Area (in %) in West Bank and Gaza in 1995 to that in 1997?
Ensure brevity in your answer.  1.02. What is the ratio of the Area (in %) in Sub-Saharan Africa (all income levels) in 1995 to that in 1998?
Your response must be concise. 0.99. What is the ratio of the Area (in %) of Germany in 1995 to that in 1998?
Your answer should be compact. 1. What is the ratio of the Area (in %) of Madagascar in 1995 to that in 1998?
Give a very brief answer. 0.95. What is the ratio of the Area (in %) of West Bank and Gaza in 1995 to that in 1998?
Provide a short and direct response. 1.08. What is the ratio of the Area (in %) in Madagascar in 1996 to that in 1997?
Provide a short and direct response. 0.98. What is the ratio of the Area (in %) of West Bank and Gaza in 1996 to that in 1997?
Your answer should be very brief. 1.01. What is the ratio of the Area (in %) of Germany in 1996 to that in 1998?
Your response must be concise. 1. What is the ratio of the Area (in %) of Madagascar in 1996 to that in 1998?
Keep it short and to the point. 0.95. What is the ratio of the Area (in %) of West Bank and Gaza in 1996 to that in 1998?
Your response must be concise. 1.07. What is the ratio of the Area (in %) of Germany in 1997 to that in 1998?
Give a very brief answer. 1. What is the ratio of the Area (in %) of West Bank and Gaza in 1997 to that in 1998?
Ensure brevity in your answer.  1.06. What is the difference between the highest and the second highest Area (in %) of Sub-Saharan Africa (all income levels)?
Offer a very short reply. 0.13. What is the difference between the highest and the second highest Area (in %) of Germany?
Provide a short and direct response. 0.1. What is the difference between the highest and the second highest Area (in %) in Madagascar?
Your answer should be compact. 1.72. What is the difference between the highest and the second highest Area (in %) in West Bank and Gaza?
Give a very brief answer. 0.66. What is the difference between the highest and the lowest Area (in %) of Sub-Saharan Africa (all income levels)?
Your answer should be compact. 0.98. What is the difference between the highest and the lowest Area (in %) of Germany?
Provide a short and direct response. 1.22. What is the difference between the highest and the lowest Area (in %) of Madagascar?
Ensure brevity in your answer.  3.68. What is the difference between the highest and the lowest Area (in %) in West Bank and Gaza?
Provide a succinct answer. 4.49. 